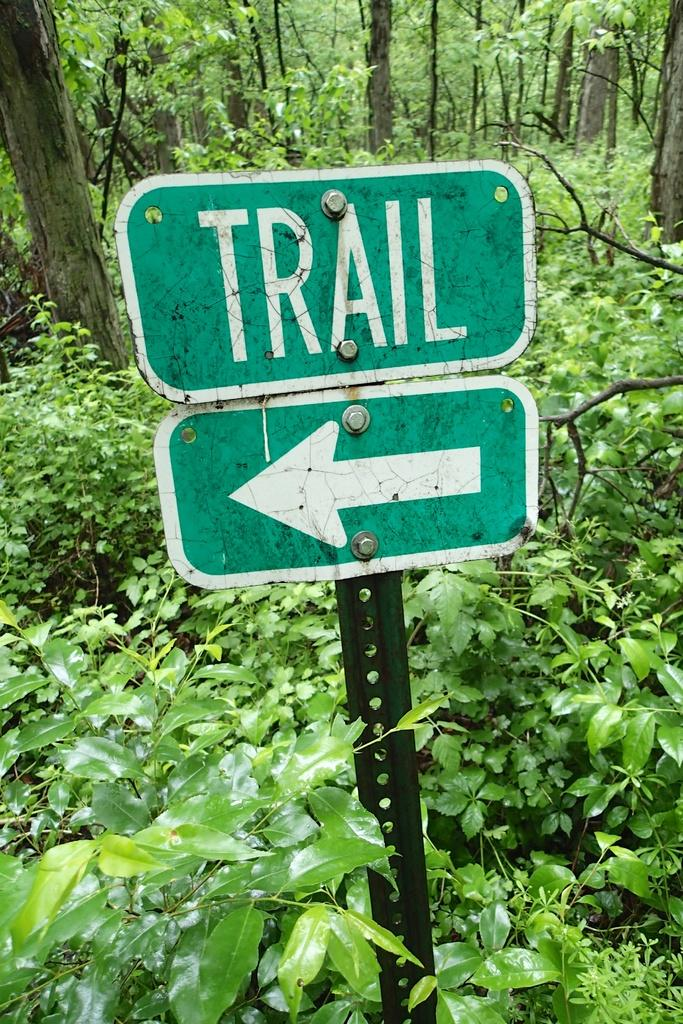<image>
Give a short and clear explanation of the subsequent image. A sign that says Trail and points to the left. 